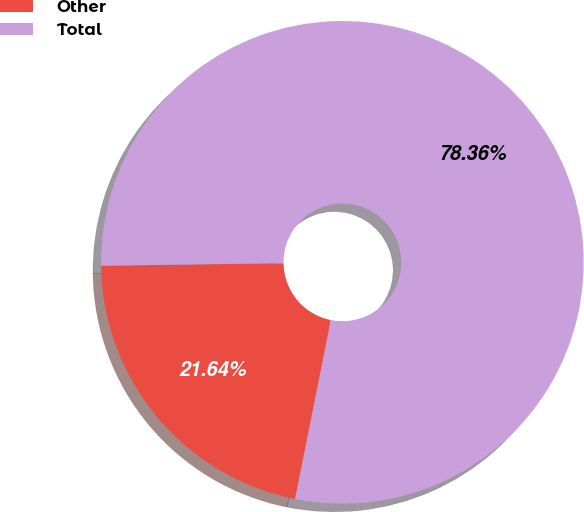Convert chart. <chart><loc_0><loc_0><loc_500><loc_500><pie_chart><fcel>Other<fcel>Total<nl><fcel>21.64%<fcel>78.36%<nl></chart> 